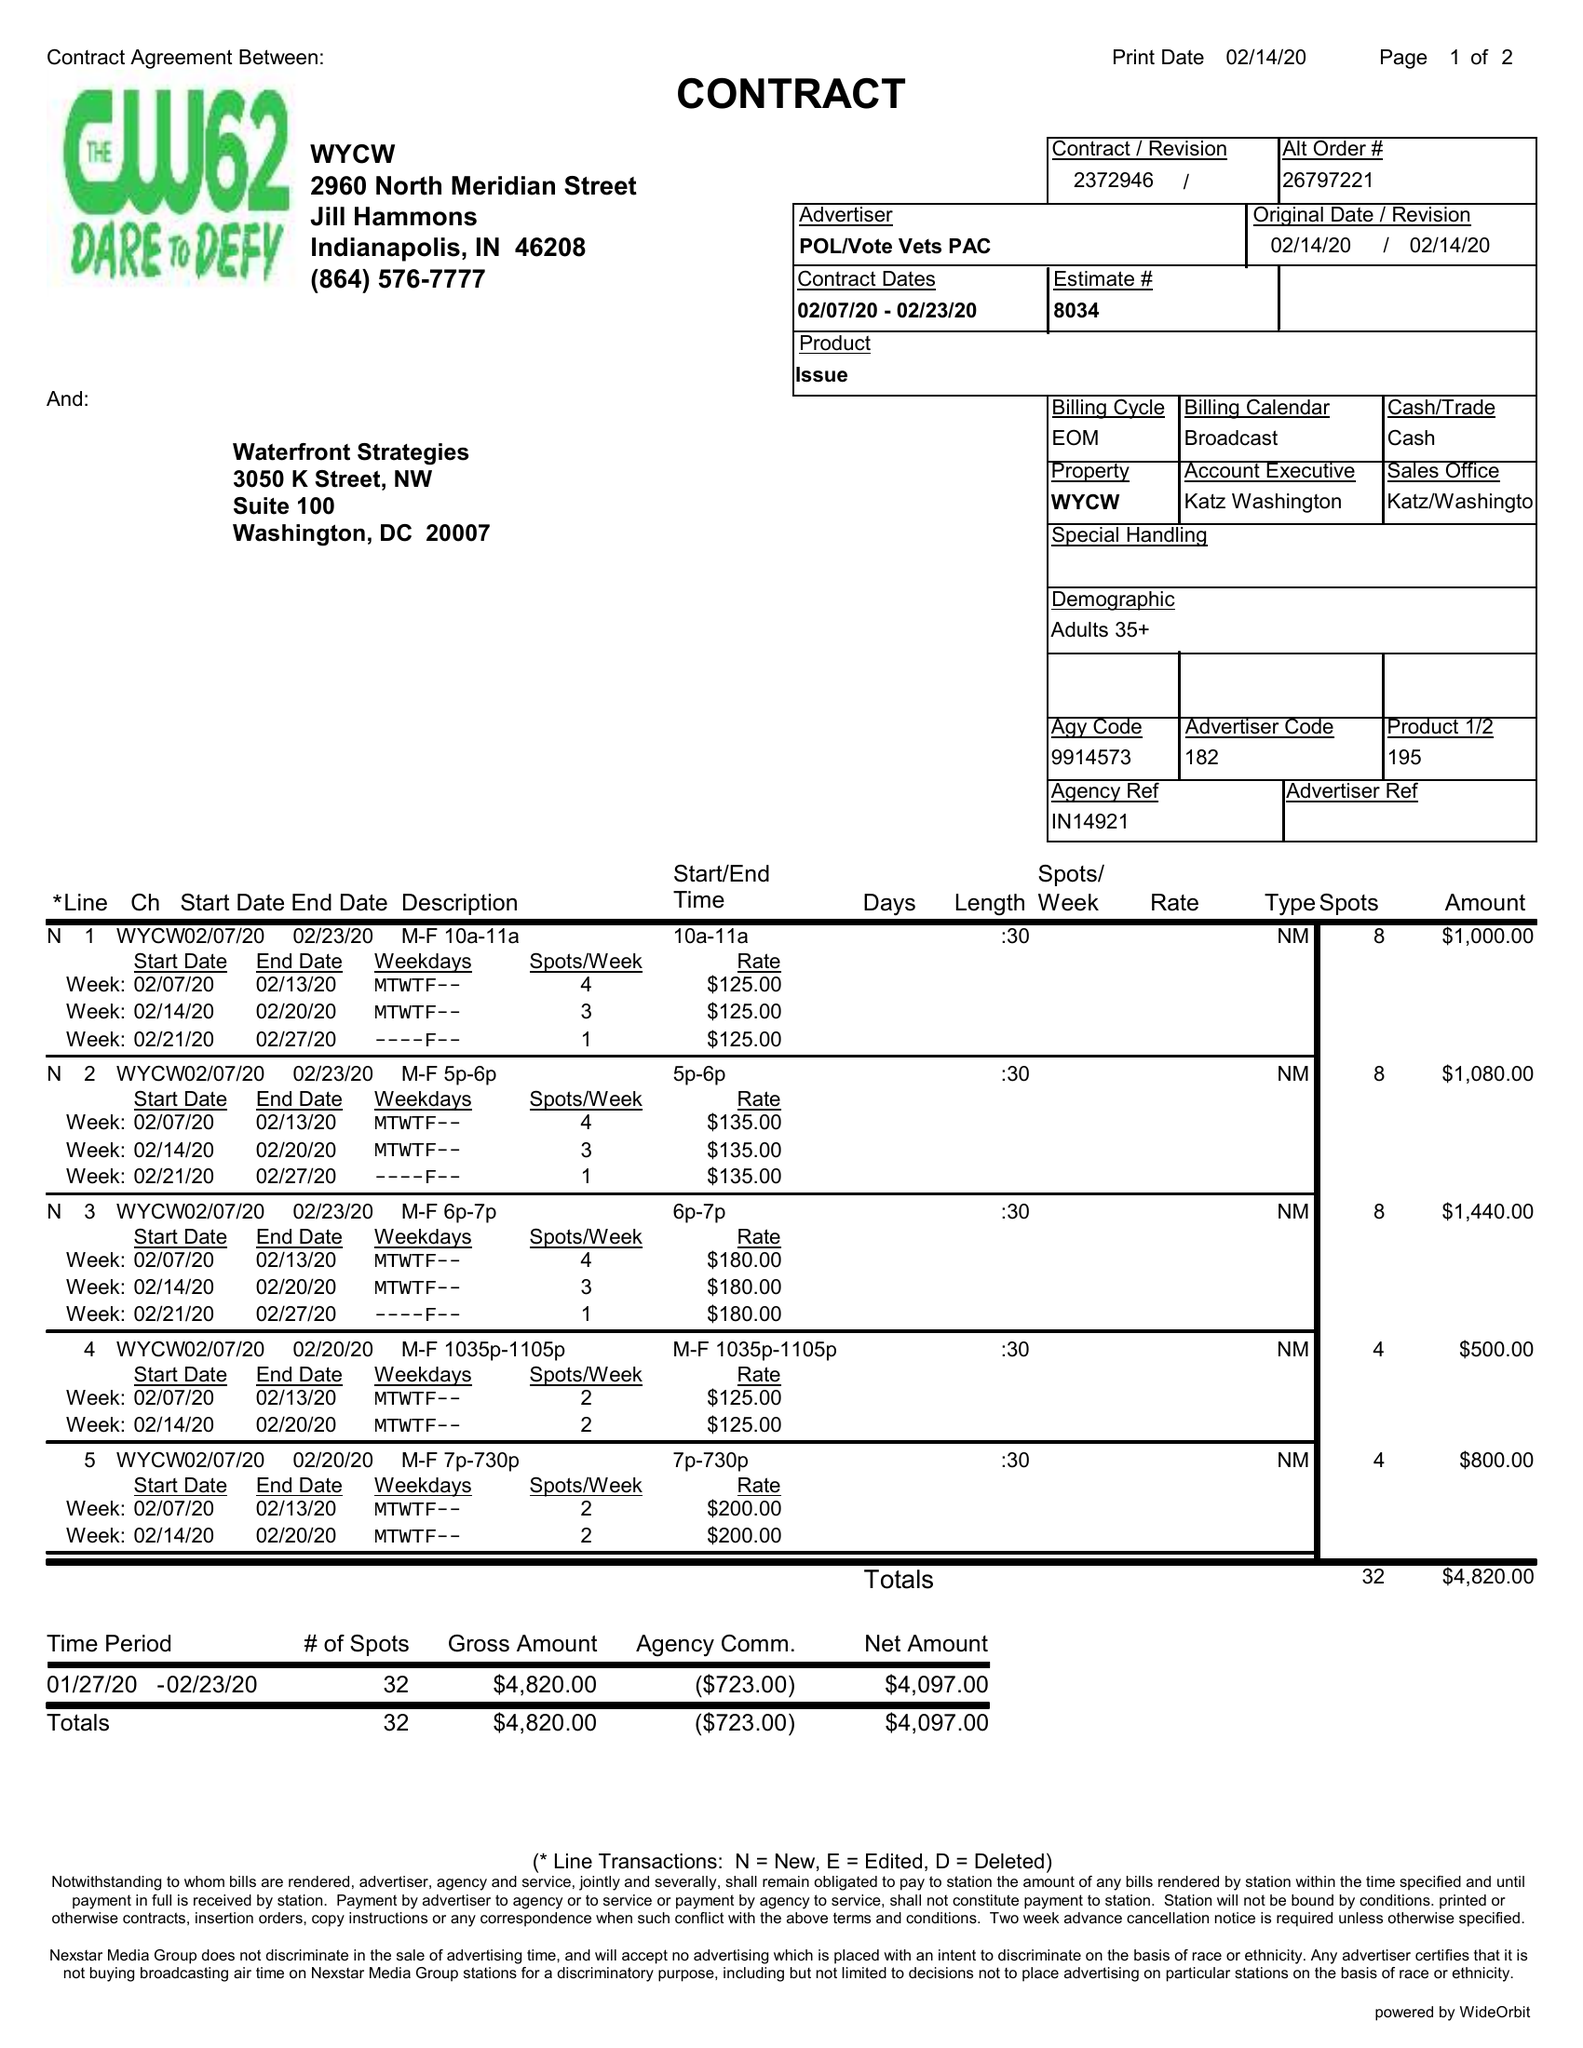What is the value for the flight_from?
Answer the question using a single word or phrase. 02/07/20 